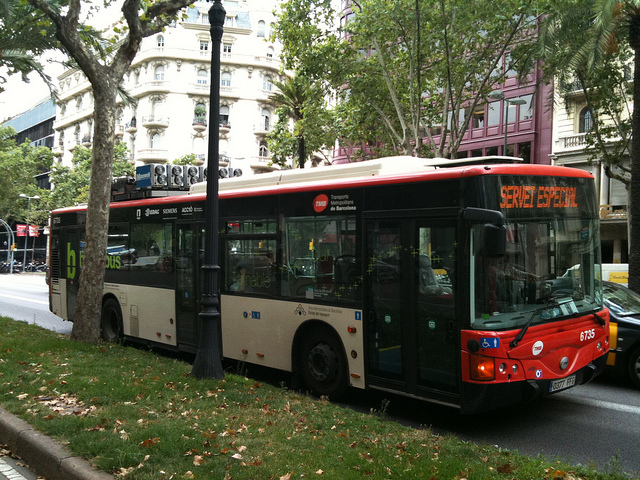Identify the text contained in this image. SERVEI ESPER 6735 n hu 